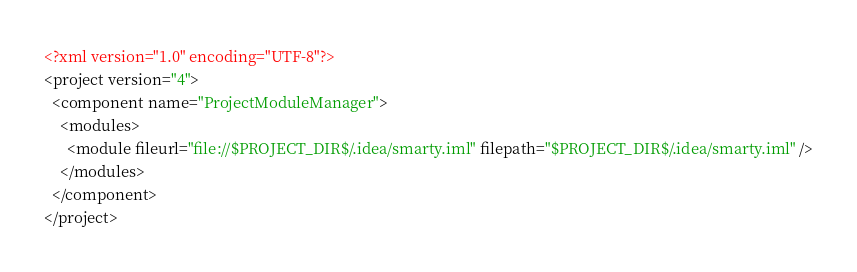<code> <loc_0><loc_0><loc_500><loc_500><_XML_><?xml version="1.0" encoding="UTF-8"?>
<project version="4">
  <component name="ProjectModuleManager">
    <modules>
      <module fileurl="file://$PROJECT_DIR$/.idea/smarty.iml" filepath="$PROJECT_DIR$/.idea/smarty.iml" />
    </modules>
  </component>
</project></code> 